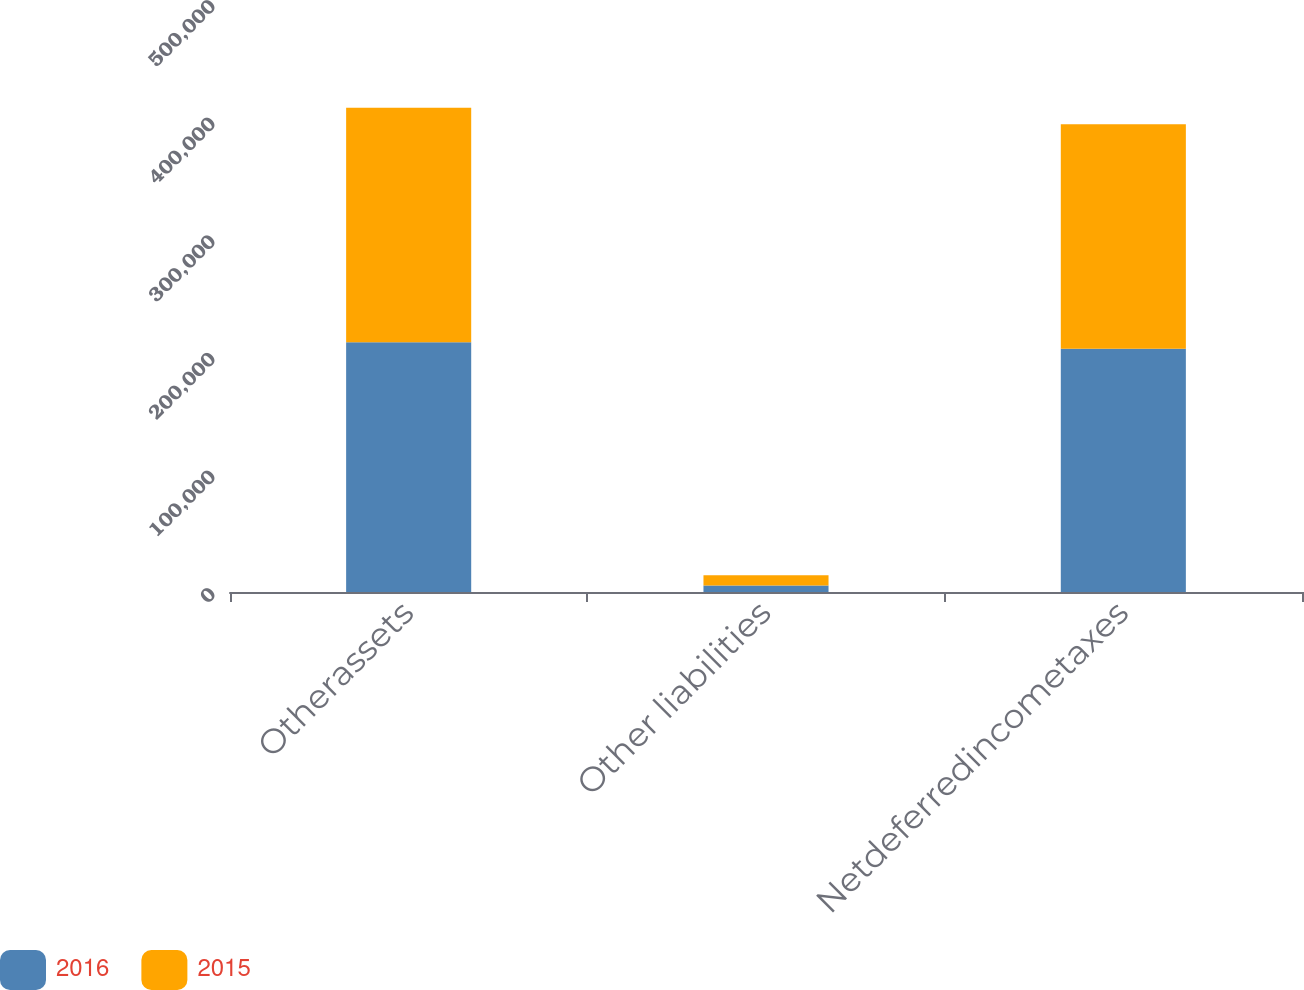Convert chart to OTSL. <chart><loc_0><loc_0><loc_500><loc_500><stacked_bar_chart><ecel><fcel>Otherassets<fcel>Other liabilities<fcel>Netdeferredincometaxes<nl><fcel>2016<fcel>212317<fcel>5452<fcel>206865<nl><fcel>2015<fcel>199563<fcel>8747<fcel>190816<nl></chart> 